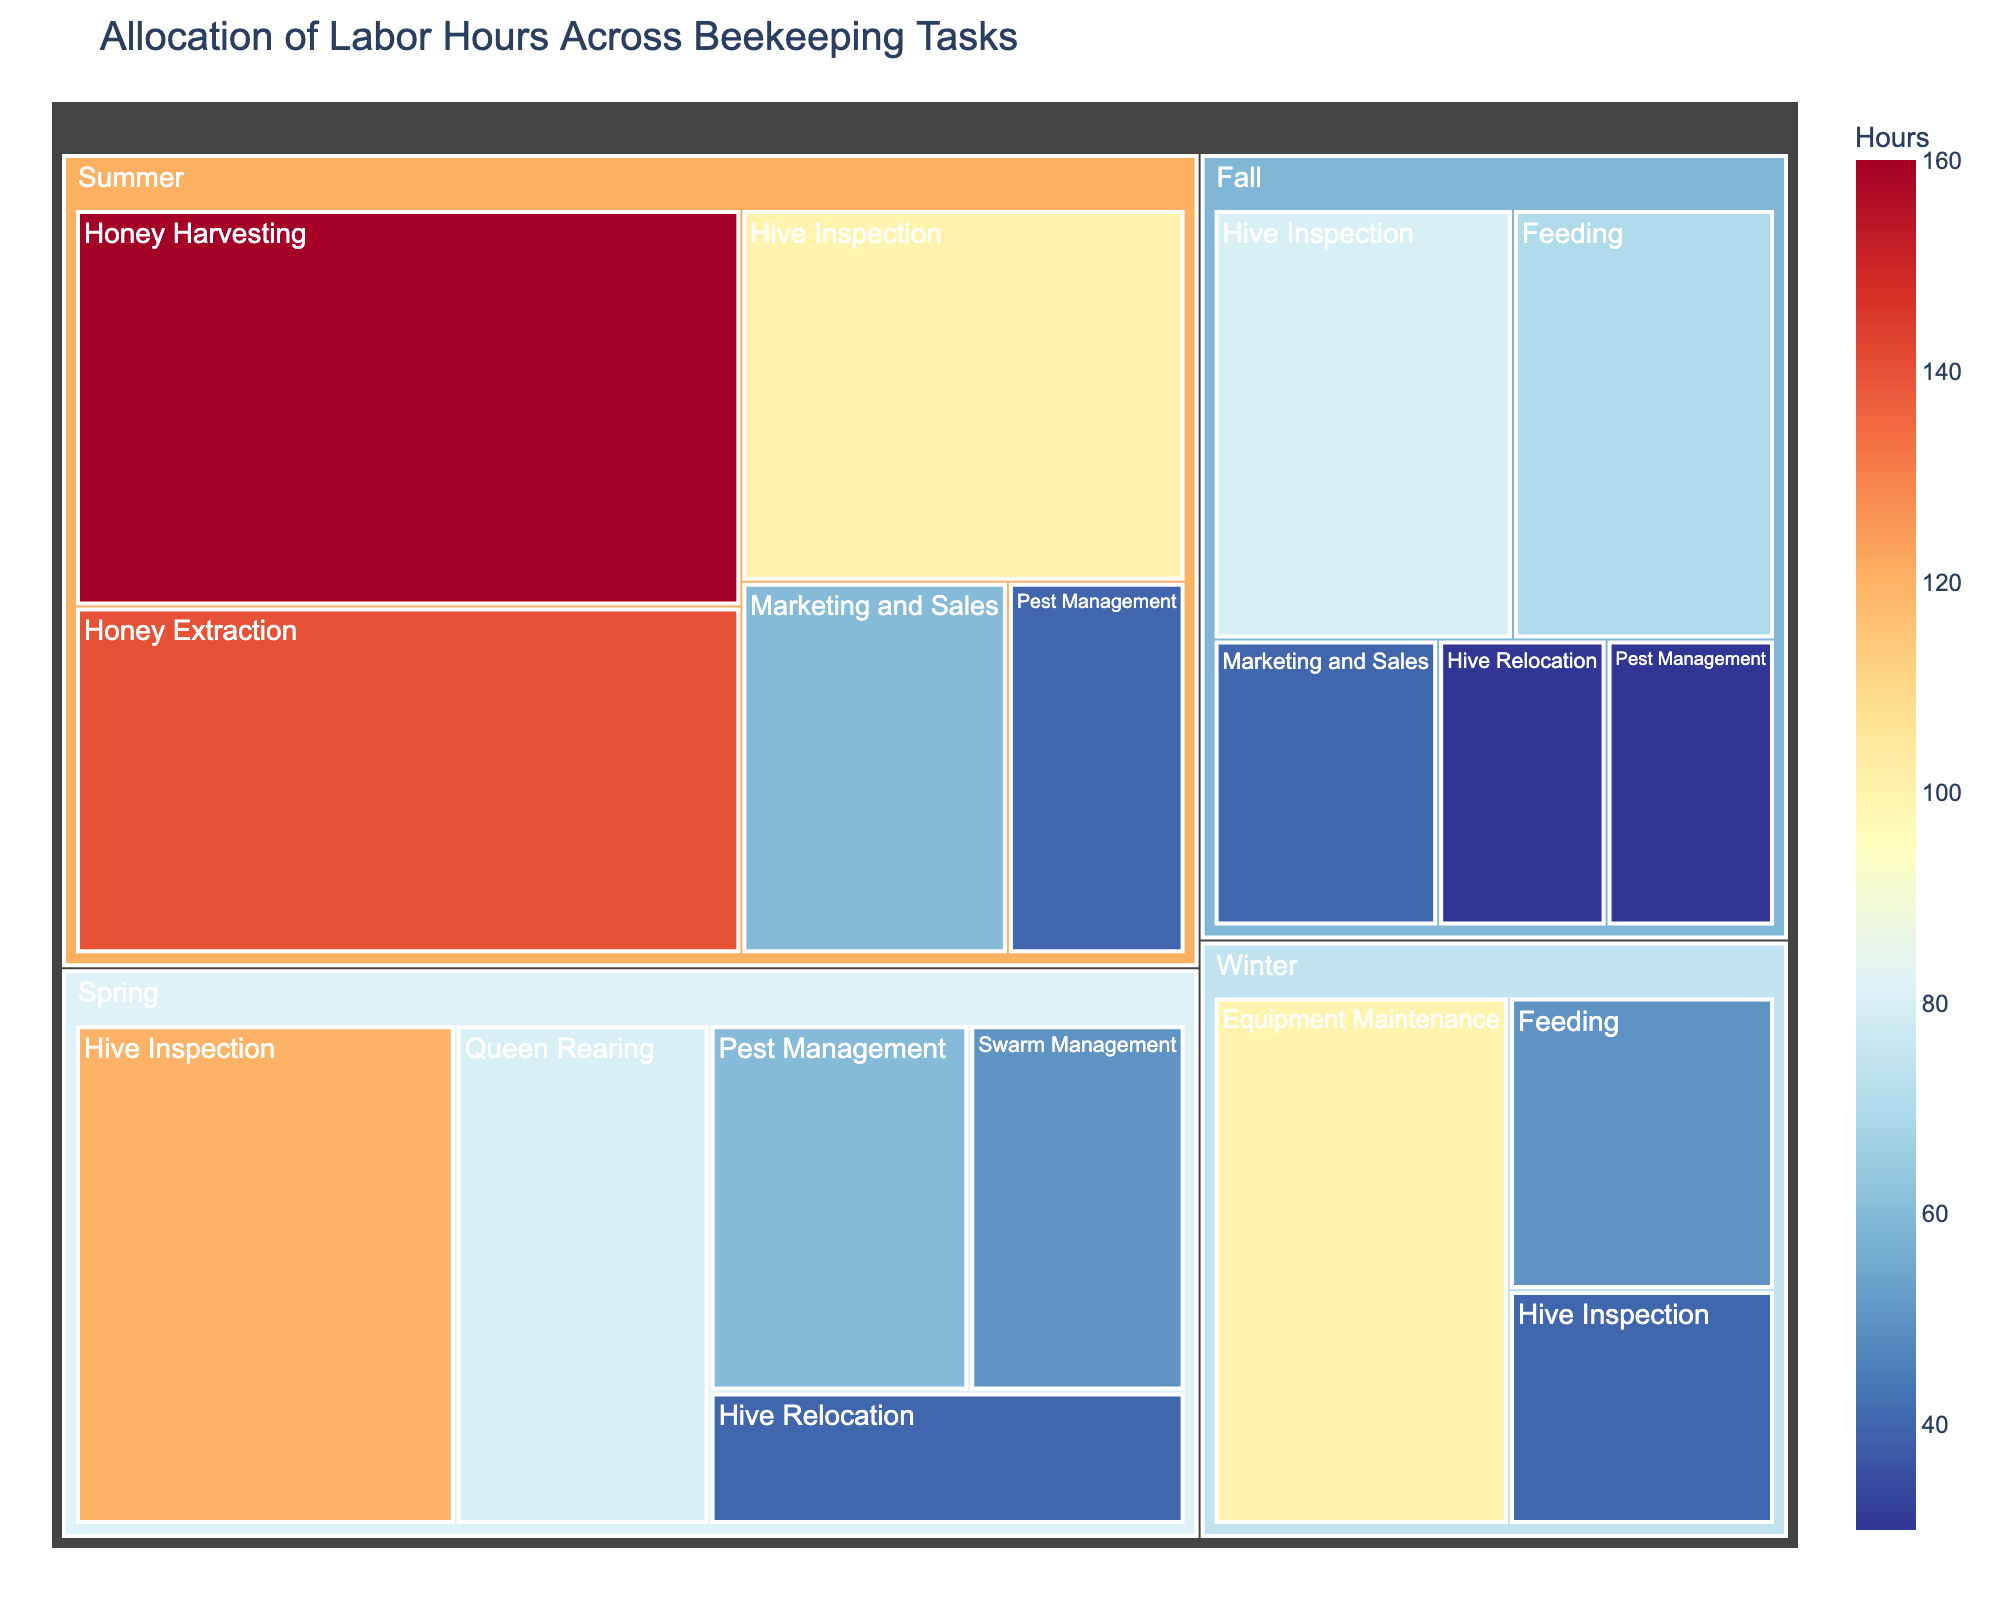What is the total number of labor hours allocated in summer? To find the total labor hours for summer, sum up the hours for all tasks performed in summer: 100 (Hive Inspection) + 160 (Honey Harvesting) + 140 (Honey Extraction) + 40 (Pest Management) + 60 (Marketing and Sales). This gives 500 hours.
Answer: 500 Which season has the least hours allocated to Hive Inspections? The hours allocated to Hive Inspections are: Spring (120), Summer (100), Fall (80), and Winter (40). Winter has the least hours allocated to Hive Inspections.
Answer: Winter What is the task with the highest number of hours in the summer? The hours allocated to tasks in summer are: Hive Inspection (100), Honey Harvesting (160), Honey Extraction (140), Pest Management (40), and Marketing and Sales (60). Honey Harvesting has the highest number of hours in the summer.
Answer: Honey Harvesting How many hours are allocated to Feeding tasks across all seasons? The hours allocated to Feeding are: Fall (70) and Winter (50). The total is 70 + 50 = 120 hours.
Answer: 120 Compare the total hours allocated to Pest Management between Spring and Summer. Which season allocated more hours? The hours allocated to Pest Management are: Spring (60) and Summer (40). Spring allocated more hours.
Answer: Spring Which task in the Treemap has the smallest allocation of labor hours and how many hours are allocated to it? The task with the smallest allocation of labor hours in the Treemap is Hive Relocation in Fall with 30 hours.
Answer: Hive Relocation in Fall, 30 hours In which season are the hours for Equipment Maintenance allocated? By examining the Treemap, the hours for Equipment Maintenance are allocated in Winter.
Answer: Winter What is the total number of hours allocated to all tasks in Winter? The hours allocated to tasks in Winter are: Hive Inspection (40), Feeding (50), and Equipment Maintenance (100). The total is 40 + 50 + 100 = 190 hours.
Answer: 190 How do the hours allocated to Queen Rearing in Spring compare to the hours for Hive Inspection in Fall? The hours for Queen Rearing in Spring (80) are compared to Hive Inspection in Fall (80). They are equal.
Answer: Equal 